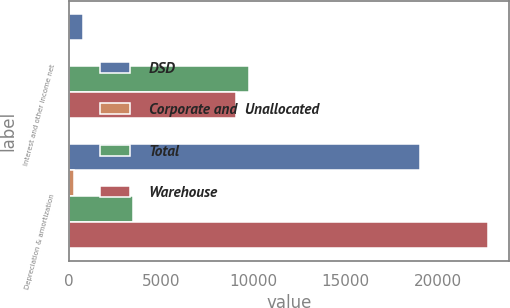<chart> <loc_0><loc_0><loc_500><loc_500><stacked_bar_chart><ecel><fcel>Interest and other income net<fcel>Depreciation & amortization<nl><fcel>DSD<fcel>755<fcel>19023<nl><fcel>Corporate and  Unallocated<fcel>2<fcel>244<nl><fcel>Total<fcel>9775<fcel>3446<nl><fcel>Warehouse<fcel>9022<fcel>22713<nl></chart> 